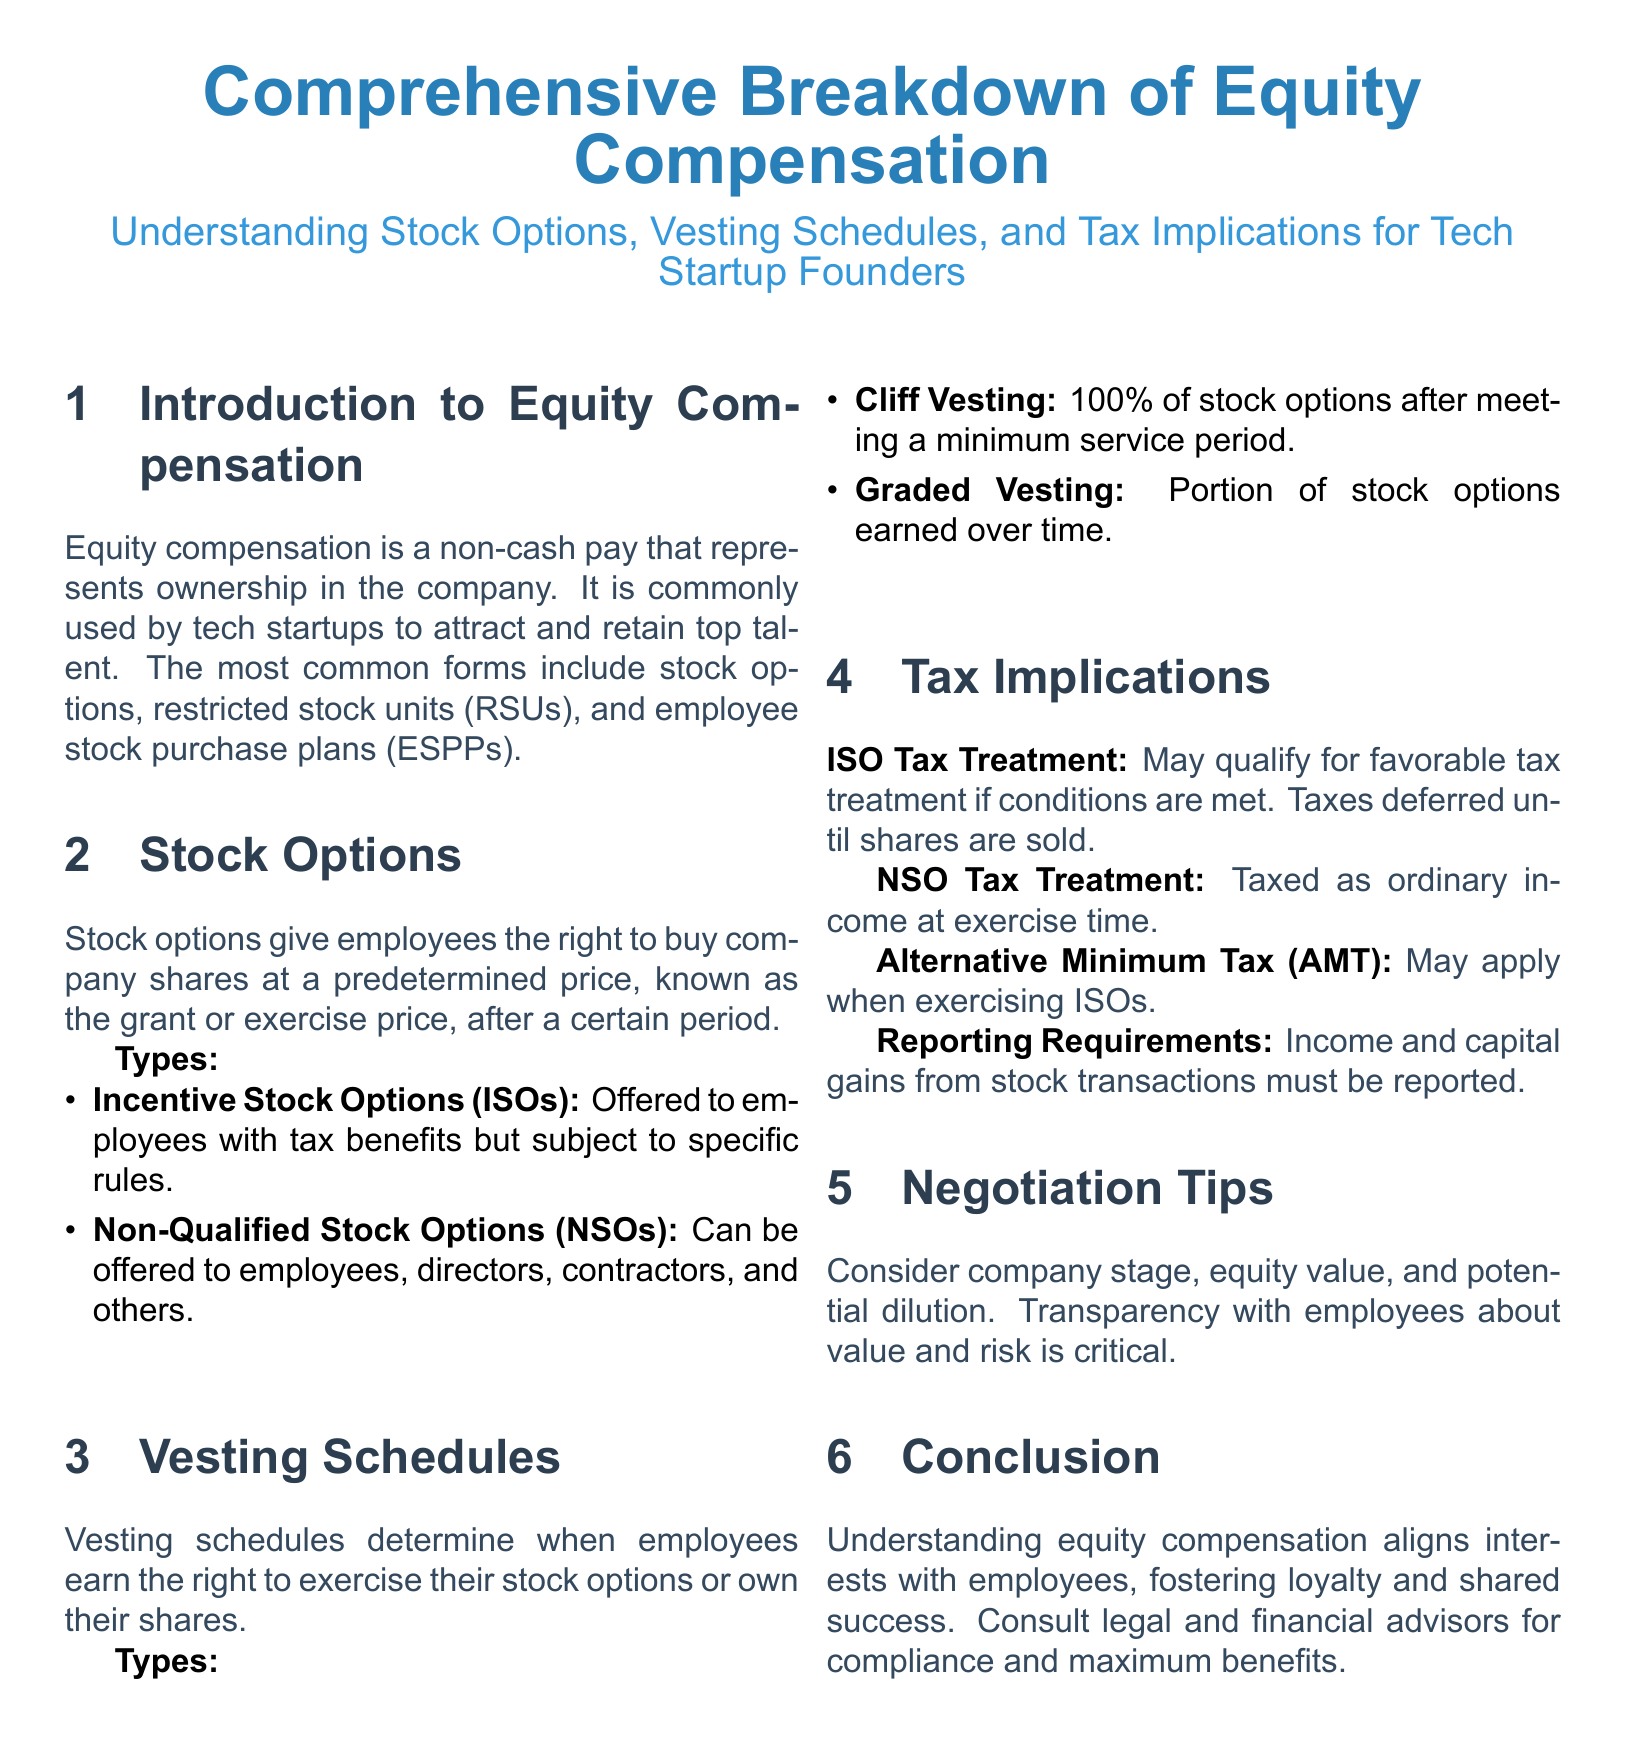What are the common forms of equity compensation? The document lists stock options, restricted stock units (RSUs), and employee stock purchase plans (ESPPs) as common forms of equity compensation.
Answer: stock options, RSUs, ESPPs What is the exercise price? The exercise price is the predetermined price at which employees can buy company shares after a certain period.
Answer: predetermined price What type of stock option is subject to specific rules? The document states that Incentive Stock Options (ISOs) are subject to specific rules.
Answer: Incentive Stock Options (ISOs) What vesting schedule includes 100% of stock options after a minimum service period? The document mentions cliff vesting as the vesting schedule that includes 100% of stock options after a minimum service period.
Answer: cliff vesting What is the tax treatment for Non-Qualified Stock Options? The tax treatment for Non-Qualified Stock Options (NSOs) is that they are taxed as ordinary income at the time of exercise.
Answer: taxed as ordinary income Under what condition may ISOs qualify for favorable tax treatment? The document states that ISOs may qualify for favorable tax treatment if conditions are met.
Answer: conditions are met What should be considered in negotiation tips? The document advises to consider company stage, equity value, and potential dilution in negotiation tips.
Answer: company stage, equity value, potential dilution What does the conclusion emphasize about understanding equity compensation? The conclusion emphasizes that understanding equity compensation aligns interests with employees.
Answer: aligns interests with employees 